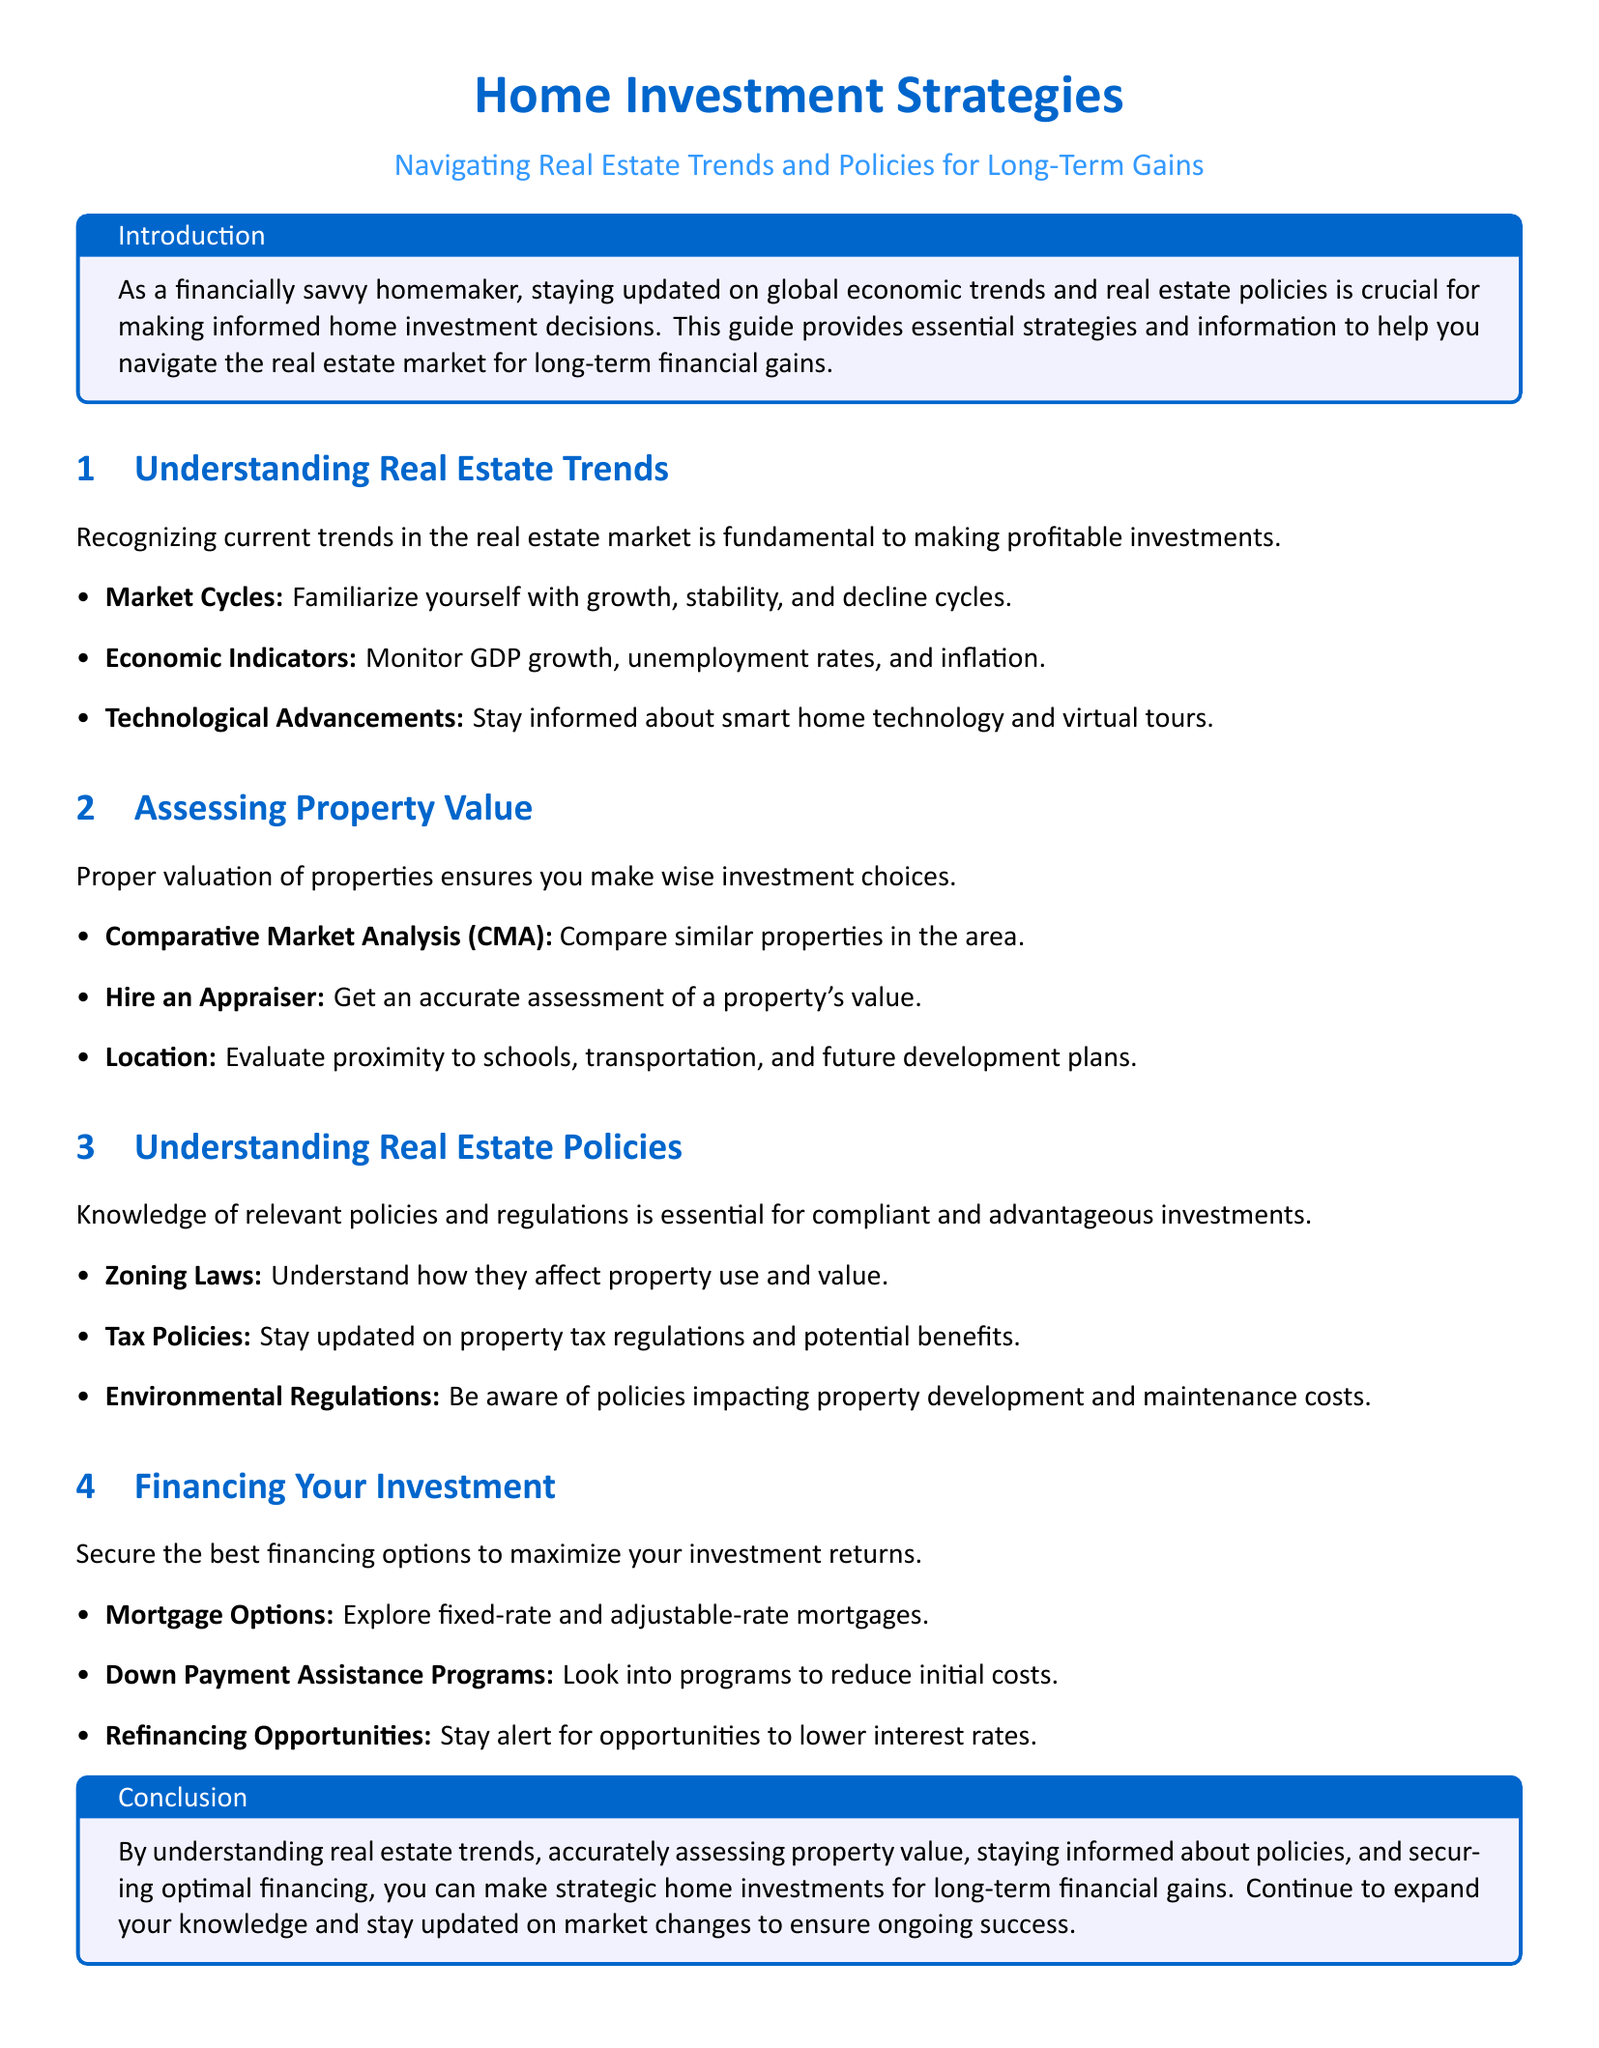What are three types of market cycles mentioned? The document lists three types of market cycles: growth, stability, and decline.
Answer: growth, stability, decline What does CMA stand for? The document states that CMA stands for Comparative Market Analysis.
Answer: Comparative Market Analysis Which mortgage options are explored? The document mentions two types of mortgage options: fixed-rate and adjustable-rate.
Answer: fixed-rate and adjustable-rate What type of regulations should investors be aware of? The document emphasizes the importance of understanding zoning laws, tax policies, and environmental regulations.
Answer: zoning laws, tax policies, environmental regulations What is essential for making wise investment choices? The document suggests that proper valuation of properties is essential for making wise investment choices.
Answer: proper valuation of properties How can you maximize investment returns? The document advises securing the best financing options to maximize investment returns.
Answer: securing the best financing options What are two economic indicators to monitor? The document states that two economic indicators to monitor are GDP growth and unemployment rates.
Answer: GDP growth, unemployment rates What are the benefits of Down Payment Assistance Programs? The document indicates that Down Payment Assistance Programs help to reduce initial costs.
Answer: reduce initial costs 